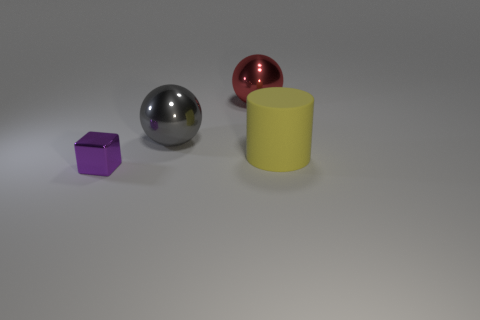Add 2 tiny purple metallic blocks. How many objects exist? 6 Subtract all cubes. How many objects are left? 3 Add 2 large red cylinders. How many large red cylinders exist? 2 Subtract 1 red balls. How many objects are left? 3 Subtract all brown spheres. Subtract all gray cylinders. How many spheres are left? 2 Subtract all large yellow metal spheres. Subtract all big red metallic objects. How many objects are left? 3 Add 4 large yellow matte things. How many large yellow matte things are left? 5 